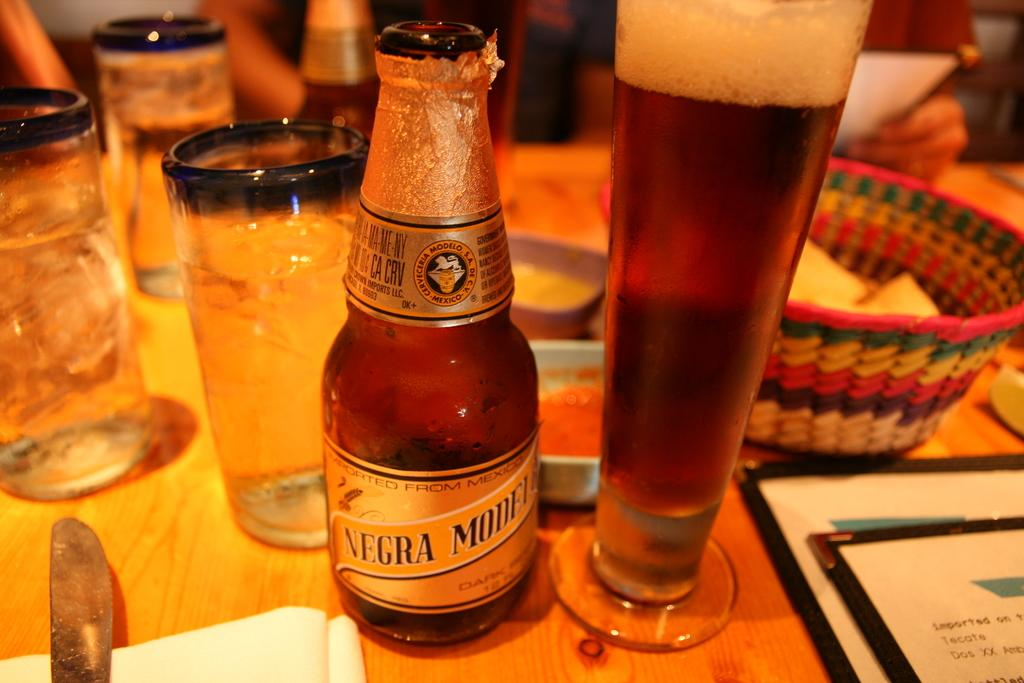<image>
Offer a succinct explanation of the picture presented. A bottle of Negra Modelo is on a restaurant table next to a cup. 